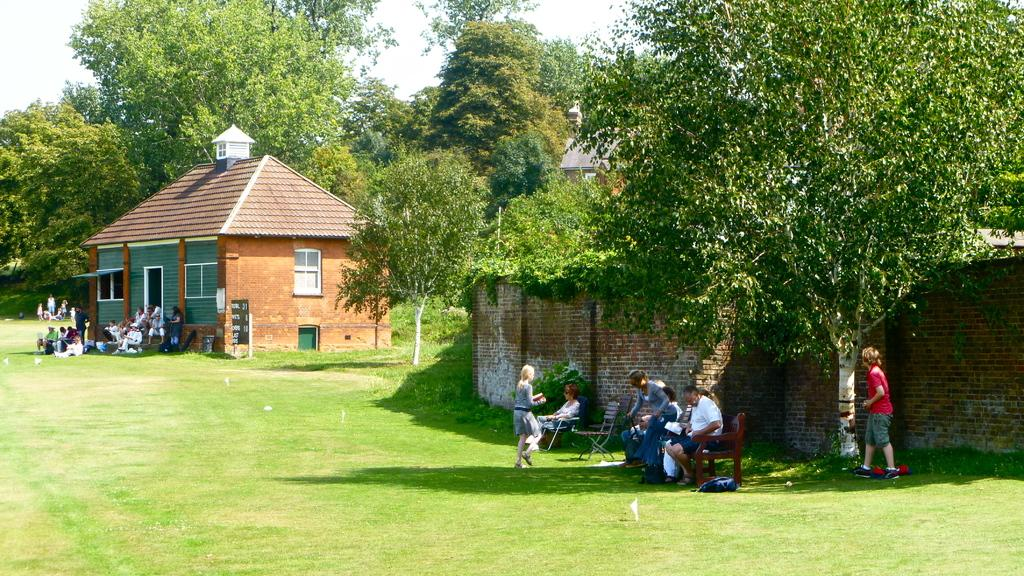What type of structures are present in the image? There are buildings in the image. What are the people in front of the buildings doing? The people are standing and sitting in front of the buildings. What can be seen in the background of the image? There are trees and the sky visible in the background of the image. What type of ear is visible on the building in the image? There is no ear present on the building in the image. What type of exchange is taking place between the people in the image? The provided facts do not mention any exchange between the people in the image. 